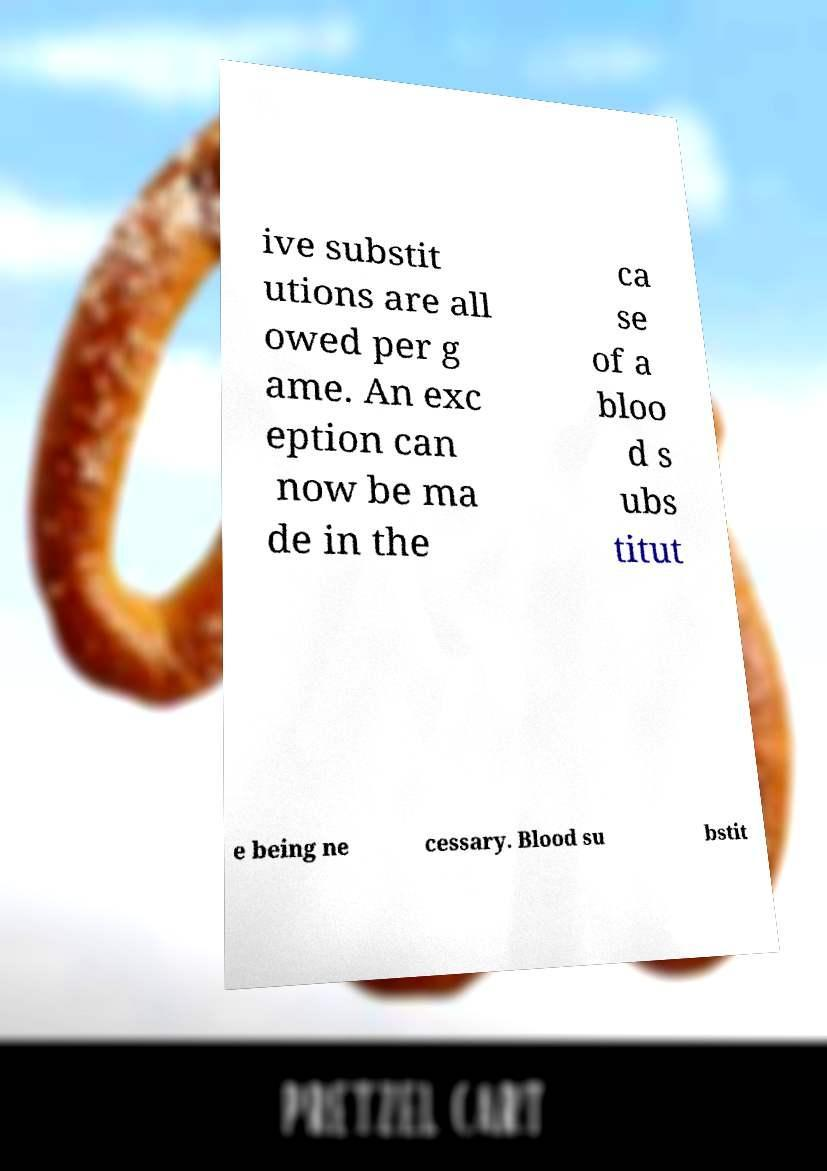Can you accurately transcribe the text from the provided image for me? ive substit utions are all owed per g ame. An exc eption can now be ma de in the ca se of a bloo d s ubs titut e being ne cessary. Blood su bstit 